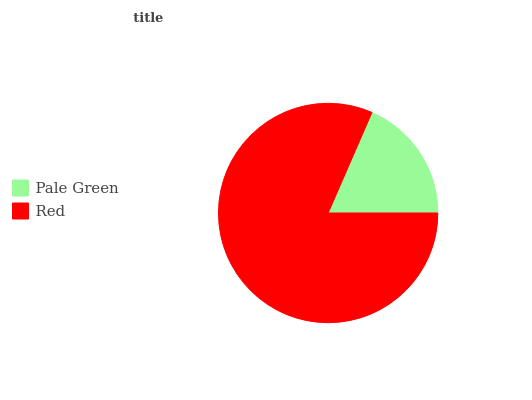Is Pale Green the minimum?
Answer yes or no. Yes. Is Red the maximum?
Answer yes or no. Yes. Is Red the minimum?
Answer yes or no. No. Is Red greater than Pale Green?
Answer yes or no. Yes. Is Pale Green less than Red?
Answer yes or no. Yes. Is Pale Green greater than Red?
Answer yes or no. No. Is Red less than Pale Green?
Answer yes or no. No. Is Red the high median?
Answer yes or no. Yes. Is Pale Green the low median?
Answer yes or no. Yes. Is Pale Green the high median?
Answer yes or no. No. Is Red the low median?
Answer yes or no. No. 